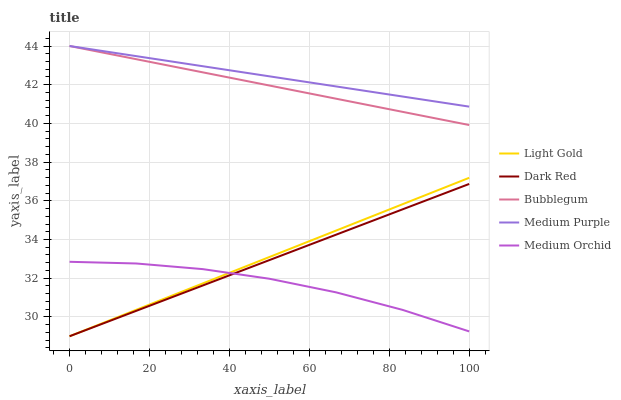Does Medium Orchid have the minimum area under the curve?
Answer yes or no. Yes. Does Medium Purple have the maximum area under the curve?
Answer yes or no. Yes. Does Dark Red have the minimum area under the curve?
Answer yes or no. No. Does Dark Red have the maximum area under the curve?
Answer yes or no. No. Is Dark Red the smoothest?
Answer yes or no. Yes. Is Medium Orchid the roughest?
Answer yes or no. Yes. Is Medium Orchid the smoothest?
Answer yes or no. No. Is Dark Red the roughest?
Answer yes or no. No. Does Dark Red have the lowest value?
Answer yes or no. Yes. Does Medium Orchid have the lowest value?
Answer yes or no. No. Does Bubblegum have the highest value?
Answer yes or no. Yes. Does Dark Red have the highest value?
Answer yes or no. No. Is Dark Red less than Medium Purple?
Answer yes or no. Yes. Is Medium Purple greater than Light Gold?
Answer yes or no. Yes. Does Dark Red intersect Light Gold?
Answer yes or no. Yes. Is Dark Red less than Light Gold?
Answer yes or no. No. Is Dark Red greater than Light Gold?
Answer yes or no. No. Does Dark Red intersect Medium Purple?
Answer yes or no. No. 